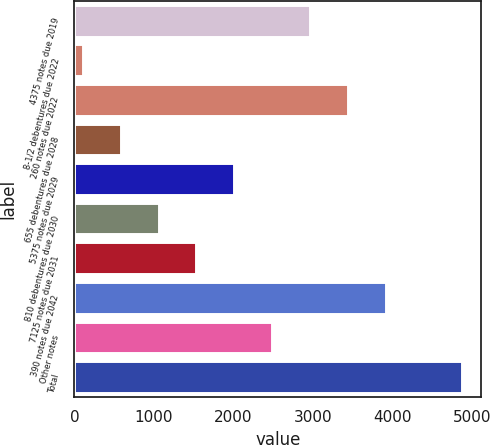Convert chart to OTSL. <chart><loc_0><loc_0><loc_500><loc_500><bar_chart><fcel>4375 notes due 2019<fcel>8-1/2 debentures due 2022<fcel>260 notes due 2022<fcel>655 debentures due 2028<fcel>5375 notes due 2029<fcel>810 debentures due 2030<fcel>7125 notes due 2031<fcel>390 notes due 2042<fcel>Other notes<fcel>Total<nl><fcel>2964.6<fcel>105<fcel>3441.2<fcel>581.6<fcel>2011.4<fcel>1058.2<fcel>1534.8<fcel>3917.8<fcel>2488<fcel>4871<nl></chart> 